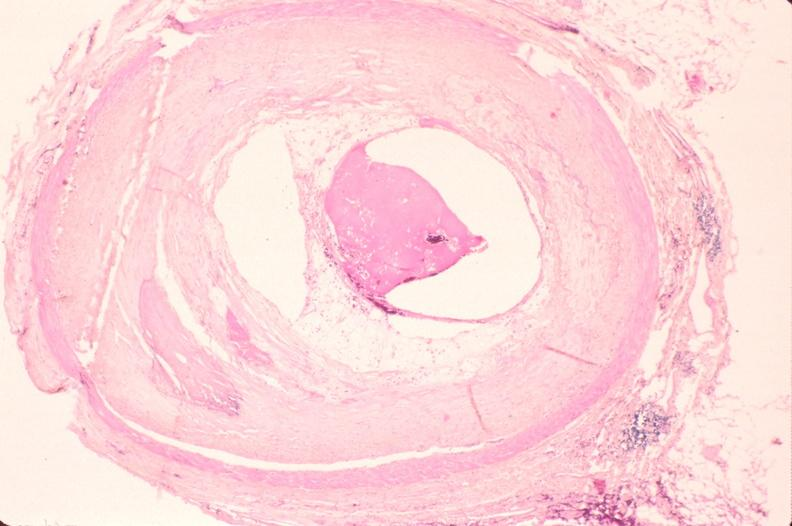what left anterior descending coronary artery?
Answer the question using a single word or phrase. Atherosclerosis 